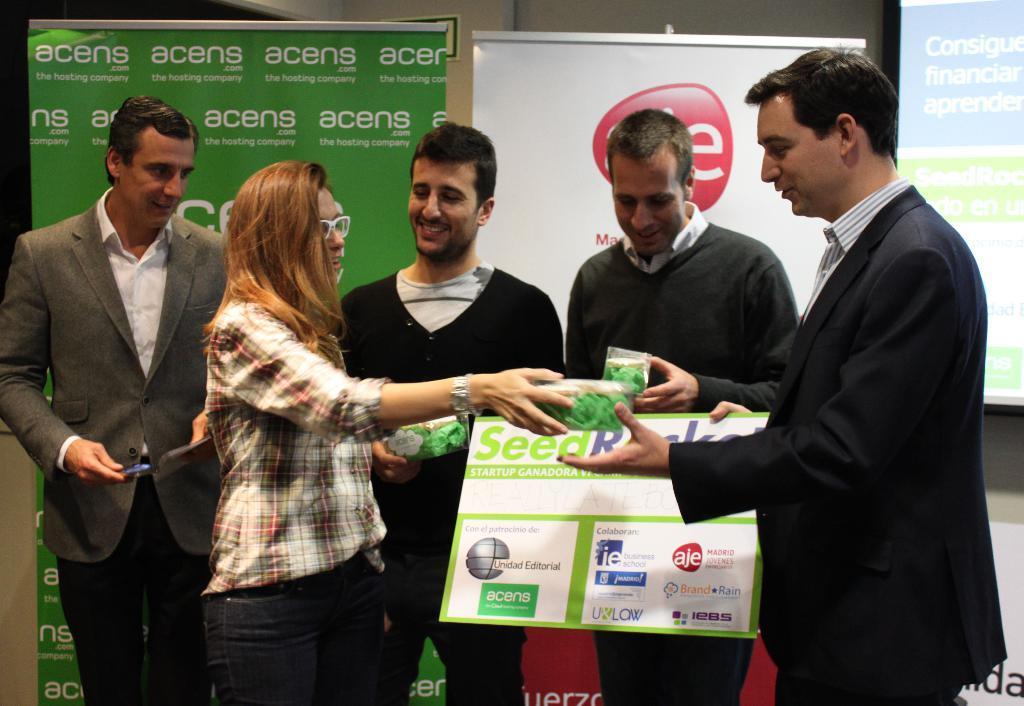Describe this image in one or two sentences. There are five persons standing. Few are holding boxes in the hand. One person is holding a board with something written on that. In the back there are banners. And the lady is wearing specs and watch. 